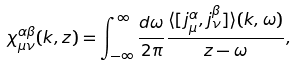Convert formula to latex. <formula><loc_0><loc_0><loc_500><loc_500>\chi _ { \mu \nu } ^ { \alpha \beta } ( { k } , z ) = \int _ { - \infty } ^ { \infty } \frac { d \omega } { 2 \pi } \frac { \langle [ j _ { \mu } ^ { \alpha } , j _ { \nu } ^ { \beta } ] \rangle ( k , \omega ) } { z - \omega } ,</formula> 